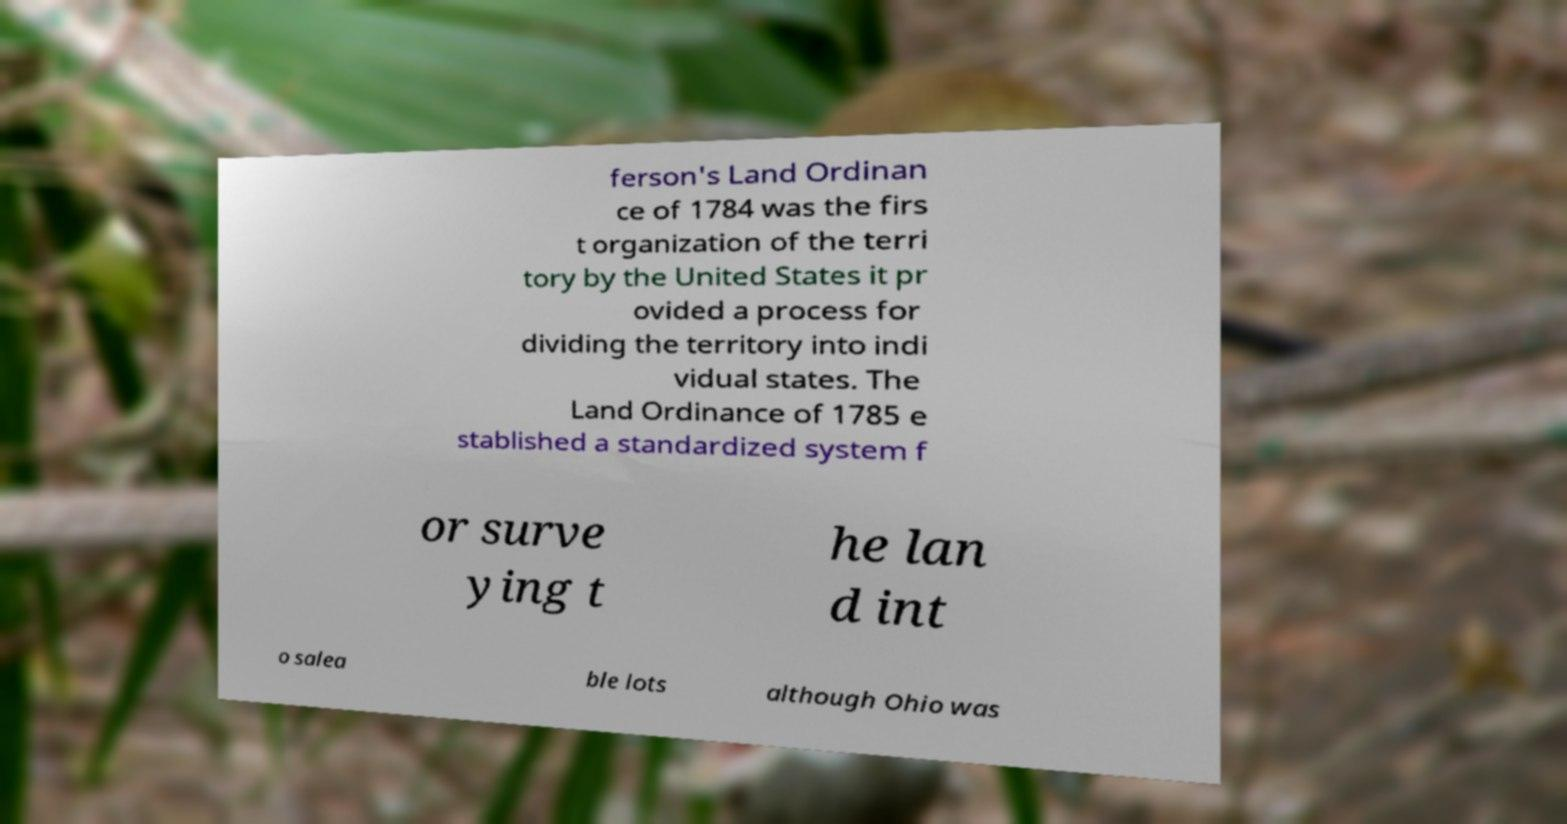Could you assist in decoding the text presented in this image and type it out clearly? ferson's Land Ordinan ce of 1784 was the firs t organization of the terri tory by the United States it pr ovided a process for dividing the territory into indi vidual states. The Land Ordinance of 1785 e stablished a standardized system f or surve ying t he lan d int o salea ble lots although Ohio was 